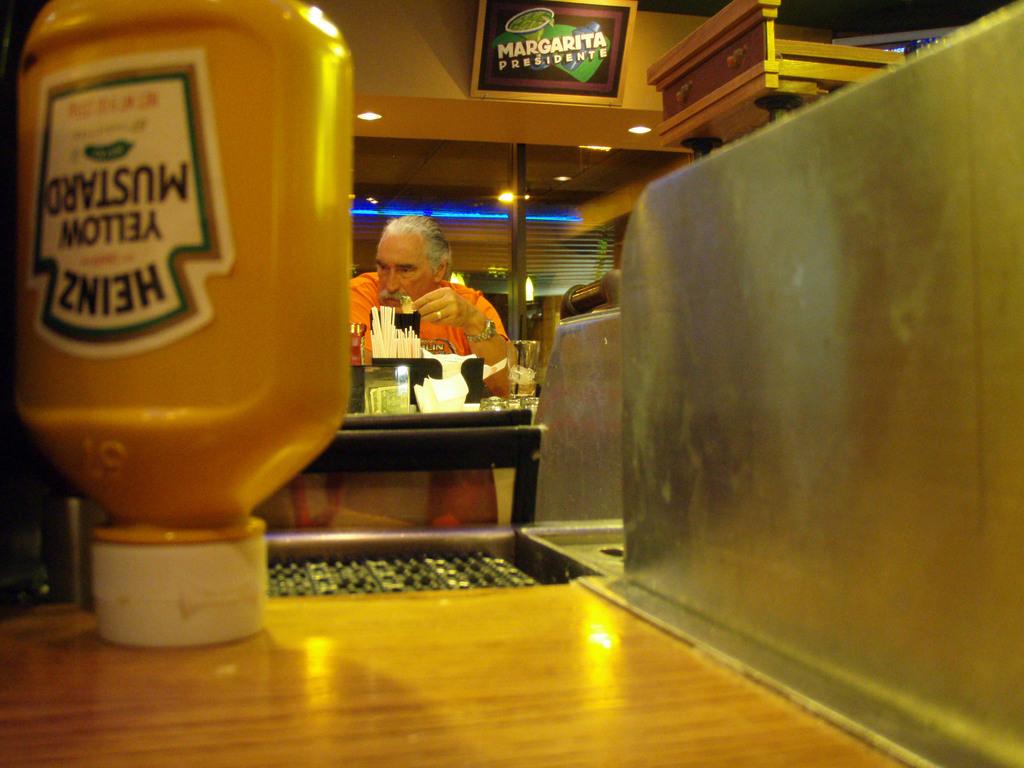What brand is the mustard?
Offer a terse response. Heinz. What does the sign say at the top?
Offer a very short reply. Margarita presidente. 